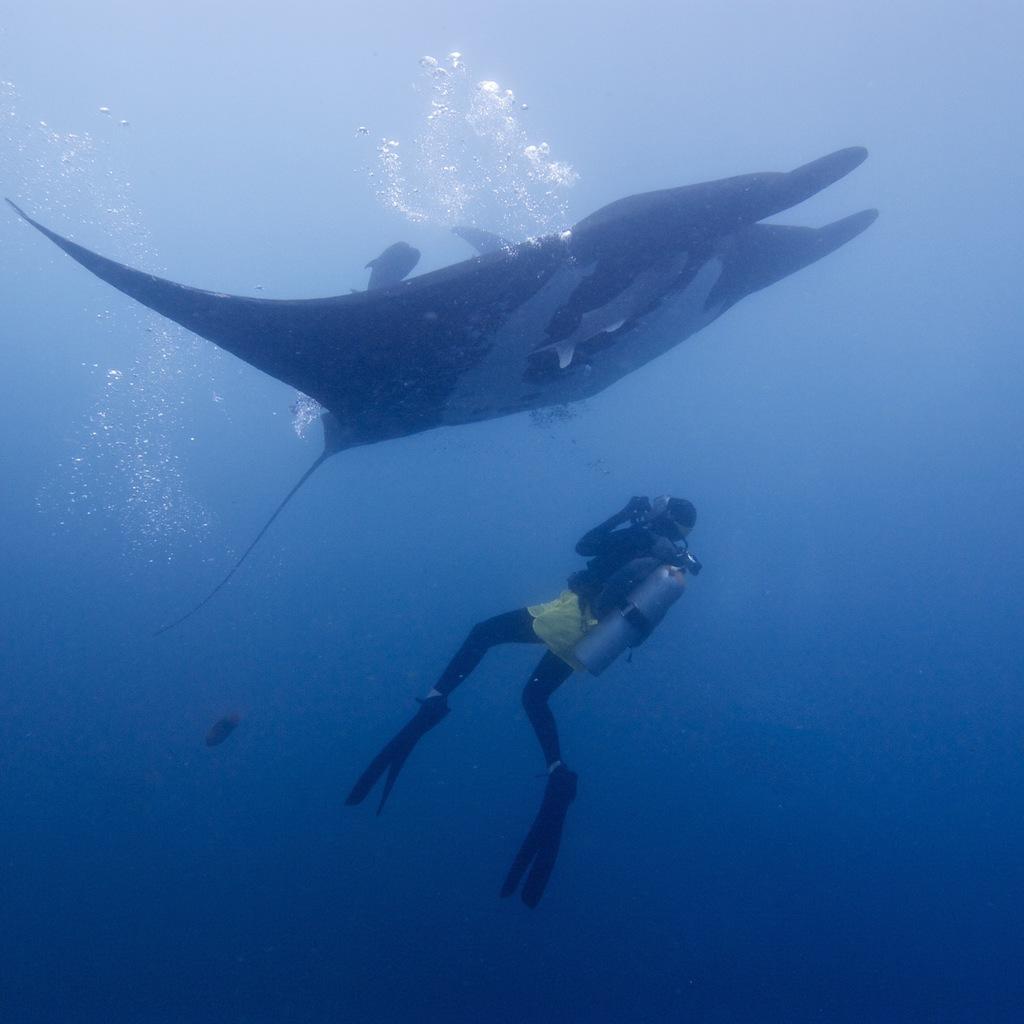In one or two sentences, can you explain what this image depicts? In the picture I can see the water animals in the water. I can see a person in the water. The person is wearing the swimsuit and there is an oxygen cylinder on the back. 